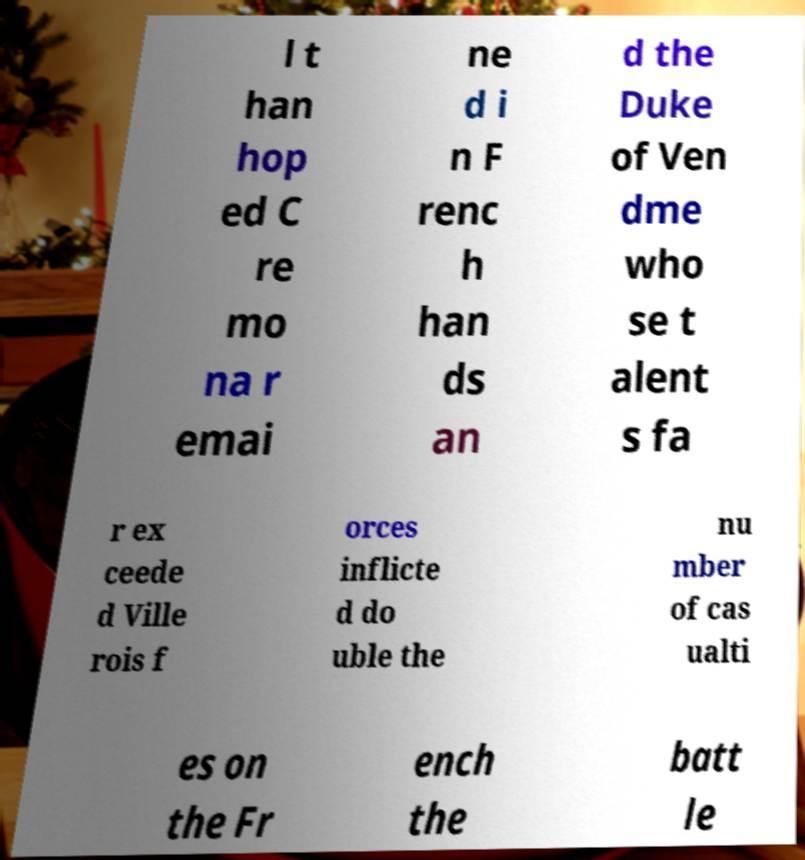Can you accurately transcribe the text from the provided image for me? l t han hop ed C re mo na r emai ne d i n F renc h han ds an d the Duke of Ven dme who se t alent s fa r ex ceede d Ville rois f orces inflicte d do uble the nu mber of cas ualti es on the Fr ench the batt le 